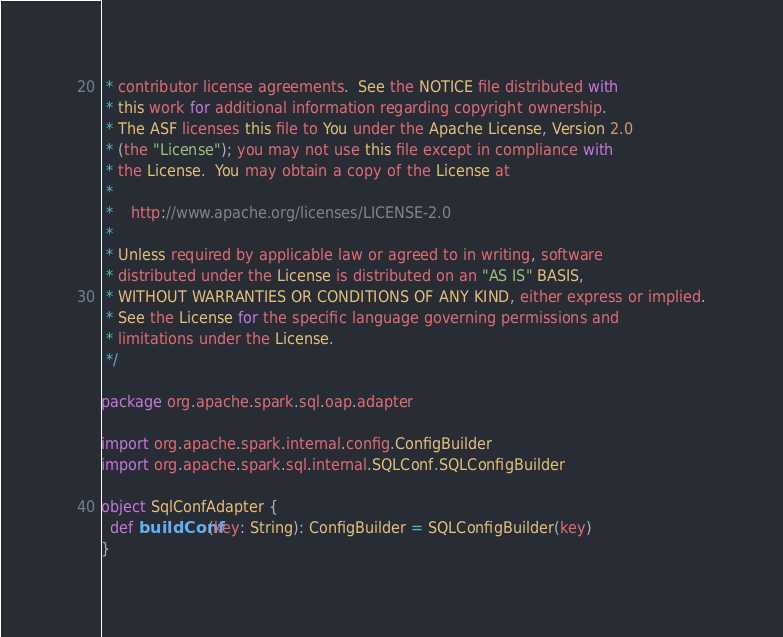<code> <loc_0><loc_0><loc_500><loc_500><_Scala_> * contributor license agreements.  See the NOTICE file distributed with
 * this work for additional information regarding copyright ownership.
 * The ASF licenses this file to You under the Apache License, Version 2.0
 * (the "License"); you may not use this file except in compliance with
 * the License.  You may obtain a copy of the License at
 *
 *    http://www.apache.org/licenses/LICENSE-2.0
 *
 * Unless required by applicable law or agreed to in writing, software
 * distributed under the License is distributed on an "AS IS" BASIS,
 * WITHOUT WARRANTIES OR CONDITIONS OF ANY KIND, either express or implied.
 * See the License for the specific language governing permissions and
 * limitations under the License.
 */

package org.apache.spark.sql.oap.adapter

import org.apache.spark.internal.config.ConfigBuilder
import org.apache.spark.sql.internal.SQLConf.SQLConfigBuilder

object SqlConfAdapter {
  def buildConf(key: String): ConfigBuilder = SQLConfigBuilder(key)
}
</code> 